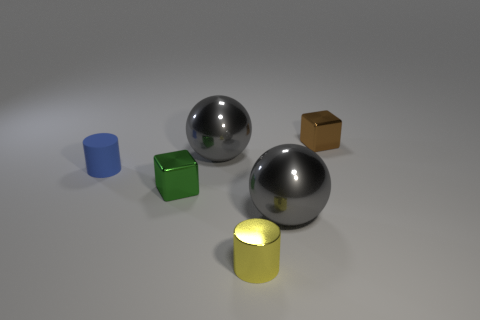Add 4 green metal things. How many objects exist? 10 Add 5 green blocks. How many green blocks are left? 6 Add 5 gray shiny balls. How many gray shiny balls exist? 7 Subtract 1 blue cylinders. How many objects are left? 5 Subtract all cubes. How many objects are left? 4 Subtract all green blocks. Subtract all gray cylinders. How many blocks are left? 1 Subtract all large cyan matte balls. Subtract all large balls. How many objects are left? 4 